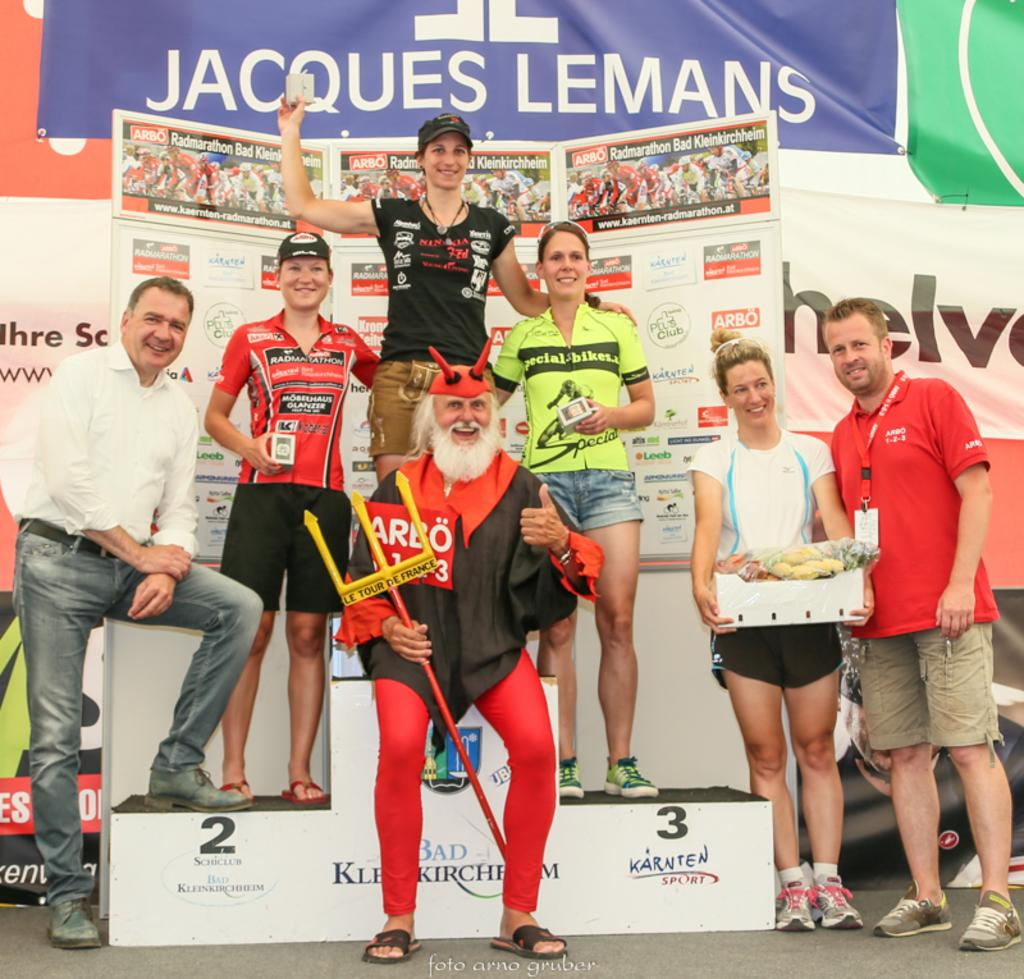<image>
Provide a brief description of the given image. A group of people posing for a picture with a banner for Jacques Lemans in the background 